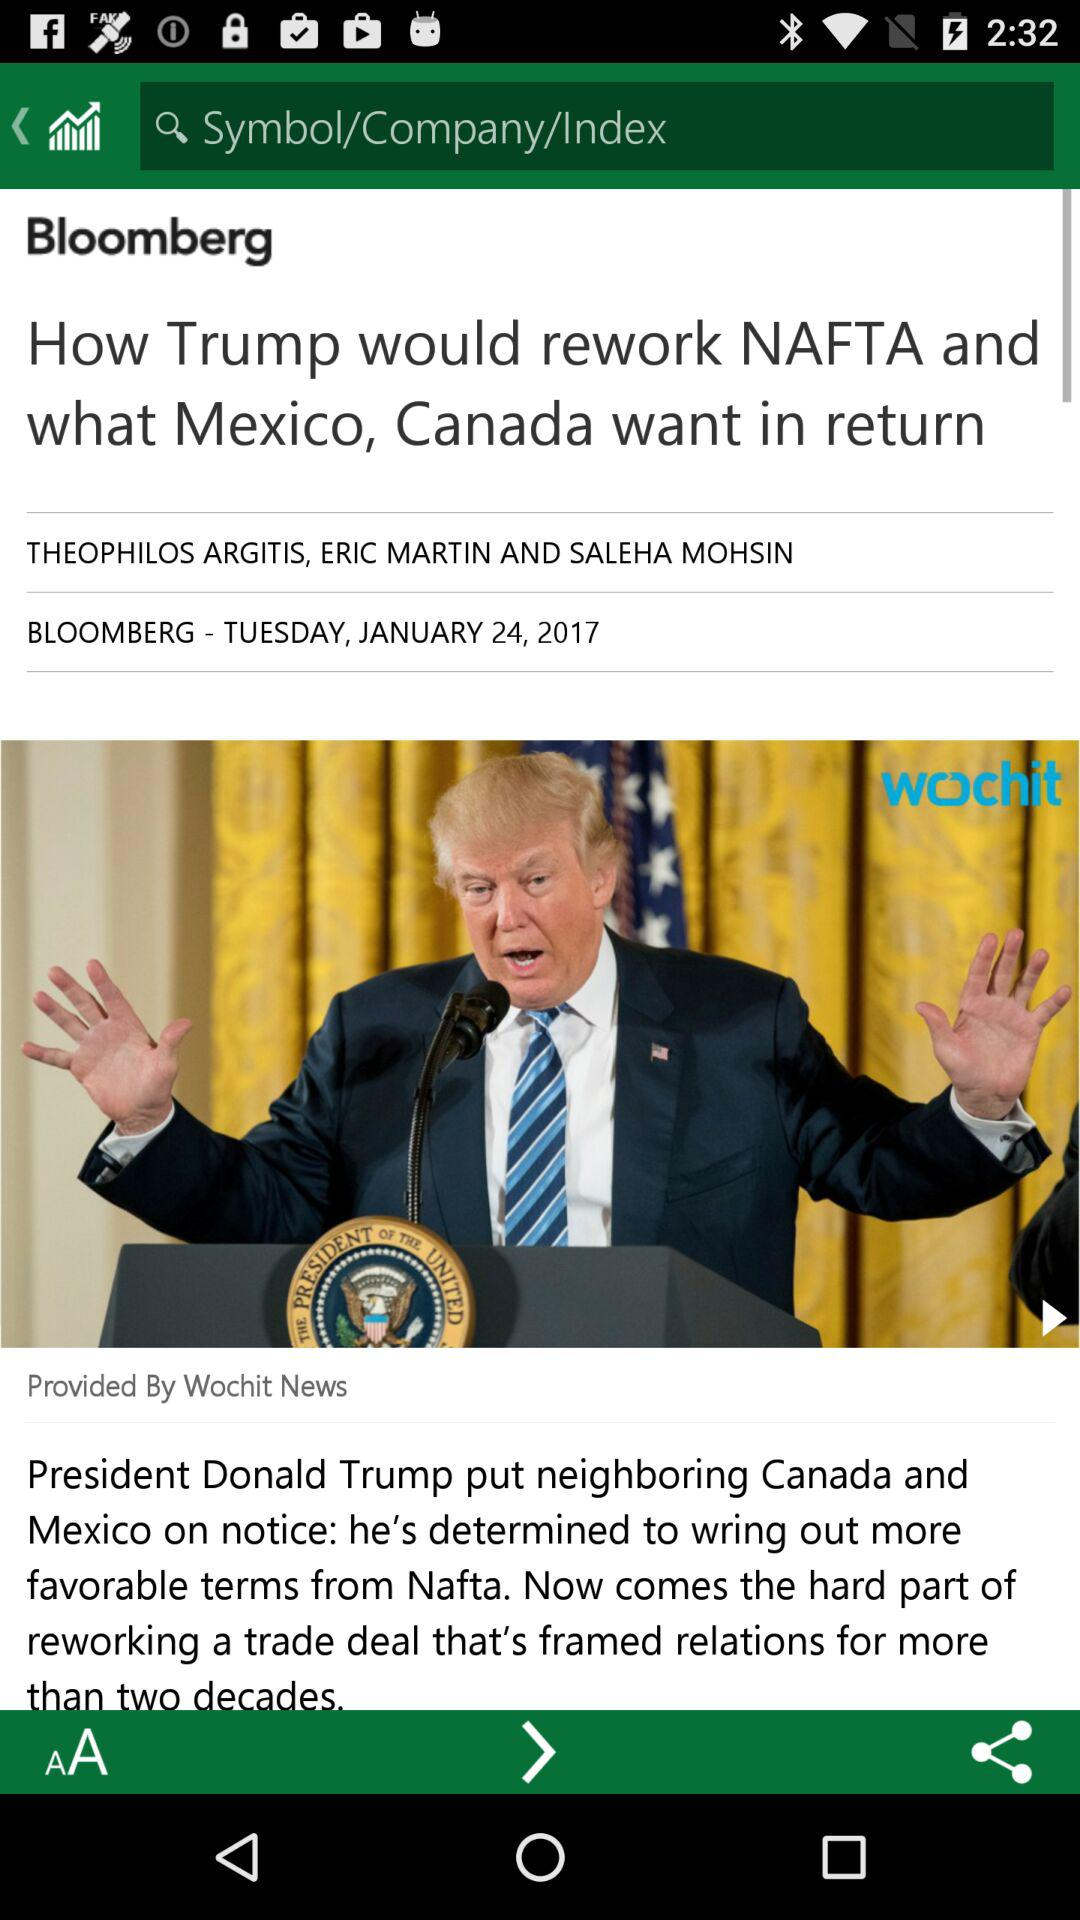Who are the authors of this article? The authors are "THEOPHILOS ARGITIS", "ERIC MARTIN", AND "SALEHA MOHSIN". 